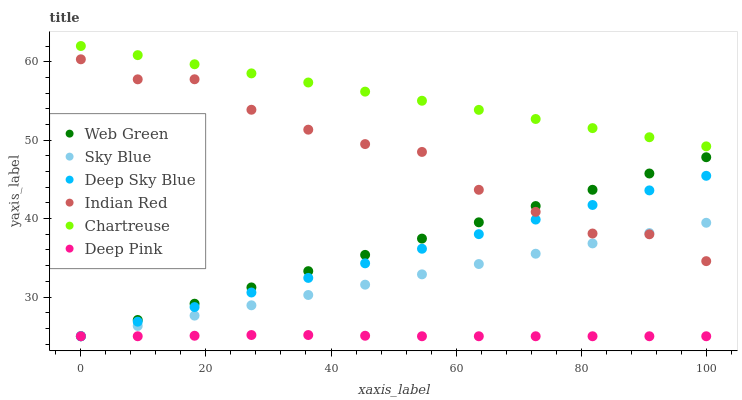Does Deep Pink have the minimum area under the curve?
Answer yes or no. Yes. Does Chartreuse have the maximum area under the curve?
Answer yes or no. Yes. Does Deep Sky Blue have the minimum area under the curve?
Answer yes or no. No. Does Deep Sky Blue have the maximum area under the curve?
Answer yes or no. No. Is Web Green the smoothest?
Answer yes or no. Yes. Is Indian Red the roughest?
Answer yes or no. Yes. Is Deep Sky Blue the smoothest?
Answer yes or no. No. Is Deep Sky Blue the roughest?
Answer yes or no. No. Does Deep Pink have the lowest value?
Answer yes or no. Yes. Does Chartreuse have the lowest value?
Answer yes or no. No. Does Chartreuse have the highest value?
Answer yes or no. Yes. Does Deep Sky Blue have the highest value?
Answer yes or no. No. Is Deep Pink less than Indian Red?
Answer yes or no. Yes. Is Chartreuse greater than Deep Pink?
Answer yes or no. Yes. Does Deep Sky Blue intersect Indian Red?
Answer yes or no. Yes. Is Deep Sky Blue less than Indian Red?
Answer yes or no. No. Is Deep Sky Blue greater than Indian Red?
Answer yes or no. No. Does Deep Pink intersect Indian Red?
Answer yes or no. No. 